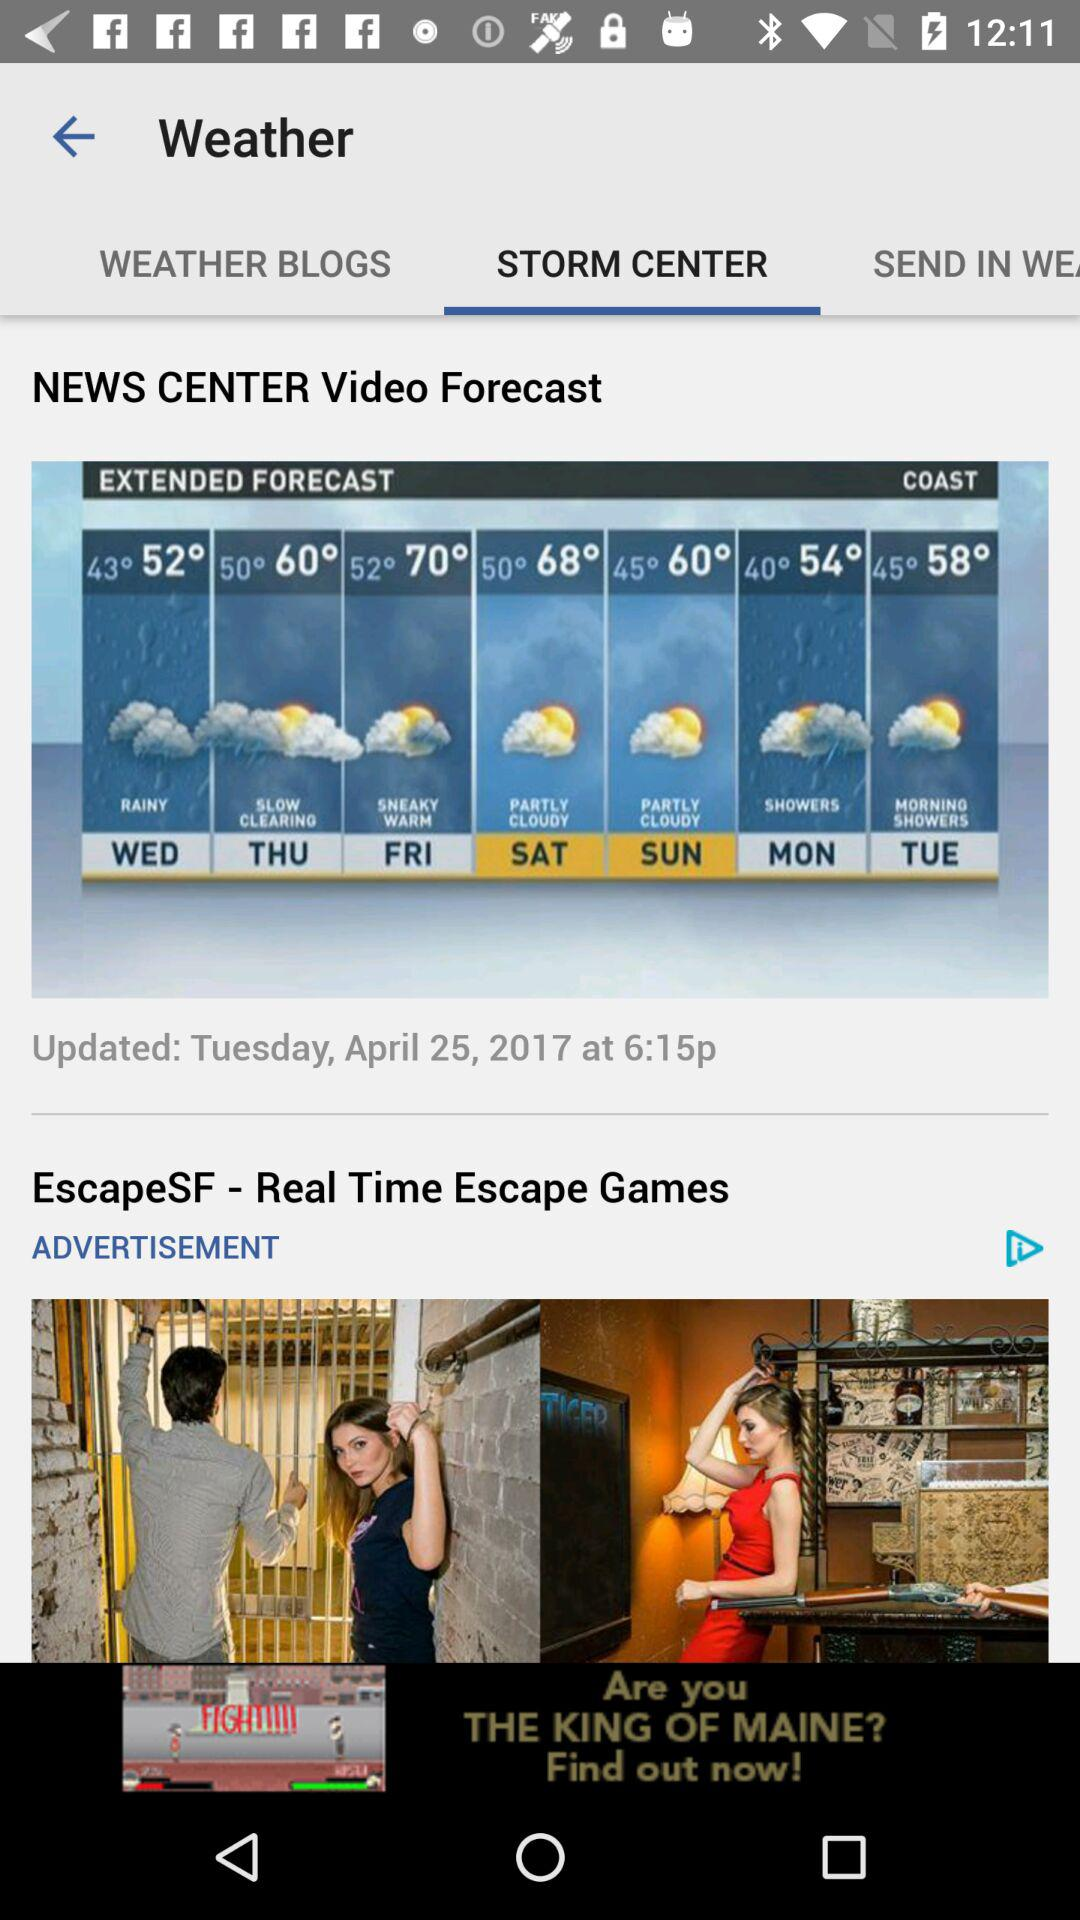How is the weather going to be on Sunday? The weather on Sunday is going to be partly cloudy. 